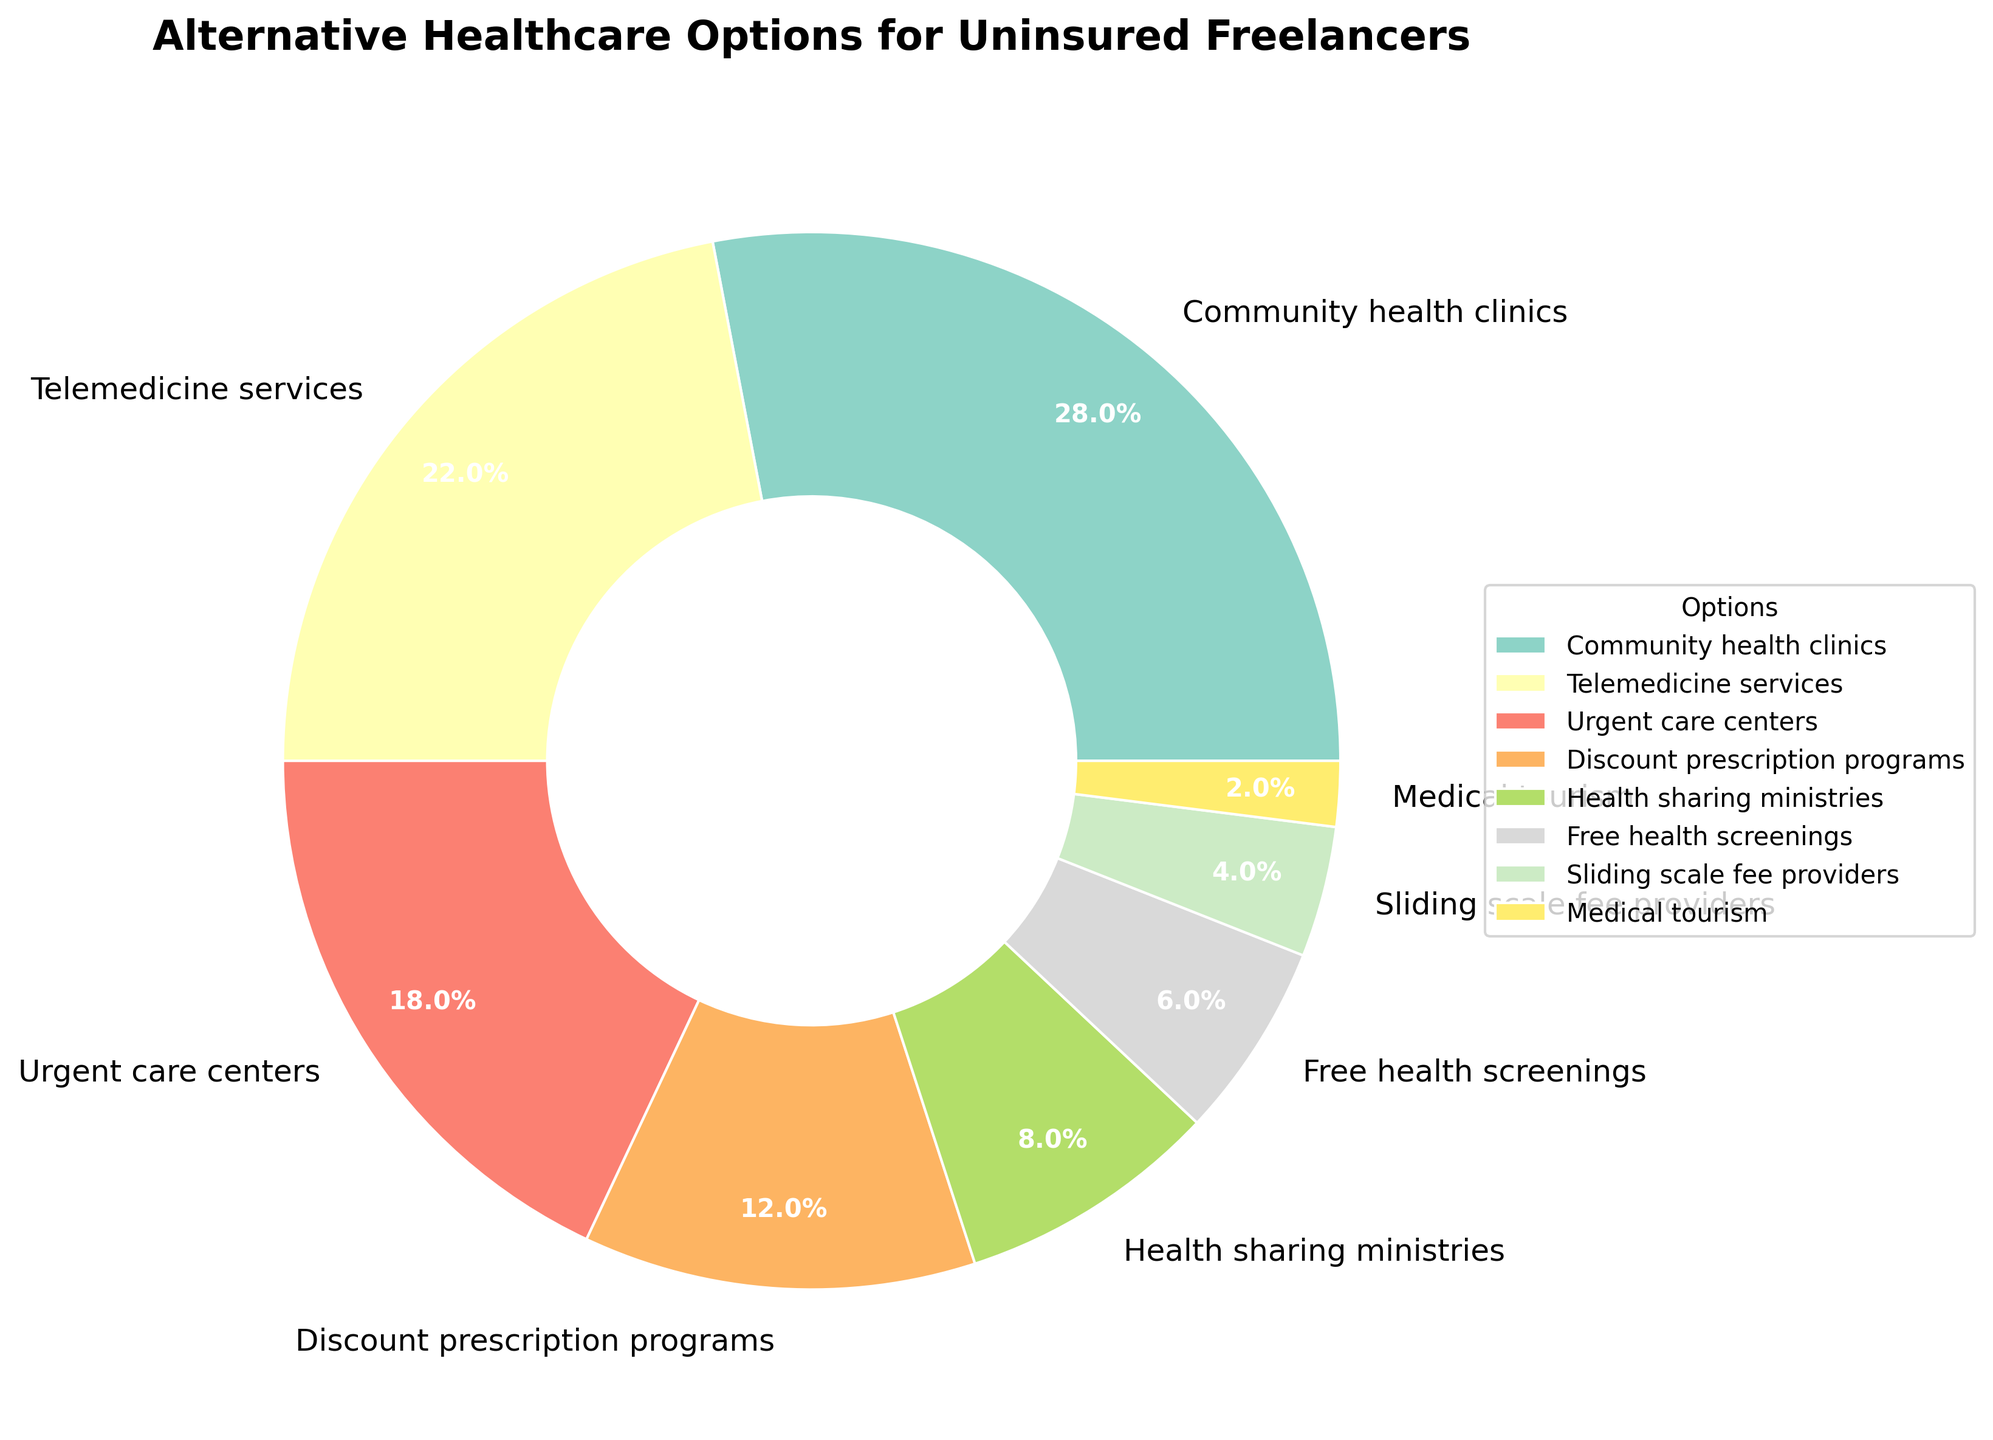what percentage of uninsured freelancers use community health clinics? Referring to the pie chart, the wedge labeled "Community health clinics" represents 28% of the total options.
Answer: 28% which option is utilized by less uninsured freelancers: health sharing ministries or medical tourism? Comparing the pie chart wedges, "Medical tourism" is listed at 2%, while "Health sharing ministries" is 8%.
Answer: Medical tourism what is the combined percentage of uninsured freelancers using urgent care centers and telemedicine services? The slice for "Urgent care centers" is 18%, and "Telemedicine services" is 22%. Summing these, 18% + 22% = 40%.
Answer: 40% is discount prescription programs usage higher or lower than sliding scale fee providers? In the pie chart, "Discount prescription programs" is shown to be 12%, while "Sliding scale fee providers" is 4%. Discount prescription programs usage is higher.
Answer: Higher what is the total percentage of uninsured freelancers who use telemedicine services, discount prescription programs, and free health screenings? According to the pie chart, "Telemedicine services" account for 22%, "Discount prescription programs" for 12%, and "Free health screenings" for 6%. Summing these values, 22% + 12% + 6% = 40%.
Answer: 40% which option accounts for the smallest percentage of usage by uninsured freelancers? The pie chart shows that "Medical tourism" is represented by the smallest slice at 2%.
Answer: Medical tourism what is the percentage difference between the usage of urgent care centers and health sharing ministries? From the chart, "Urgent care centers" is 18%, and "Health sharing ministries" is 8%. The difference is 18% - 8% = 10%.
Answer: 10% which two options combined have a lower usage percentage than community health clinics? Adding "Discount prescription programs" (12%) and "Sliding scale fee providers" (4%) gives a total of 12% + 4% = 16%, which is less than "Community health clinics" at 28%.
Answer: Discount prescription programs and Sliding scale fee providers what percentage of usage is represented by options that exceed 20%? The pie chart shows "Community health clinics" at 28% and "Telemedicine services" at 22%, both above 20%. Summing these values gives 28% + 22% = 50%.
Answer: 50% what is the percentage of uninsured freelancers using health sharing ministries when compared to urgent care centers in a ratio? The percentages for "Health sharing ministries" and "Urgent care centers" are 8% and 18%, respectively. The ratio is 8:18, which simplifies to 4:9.
Answer: 4:9 